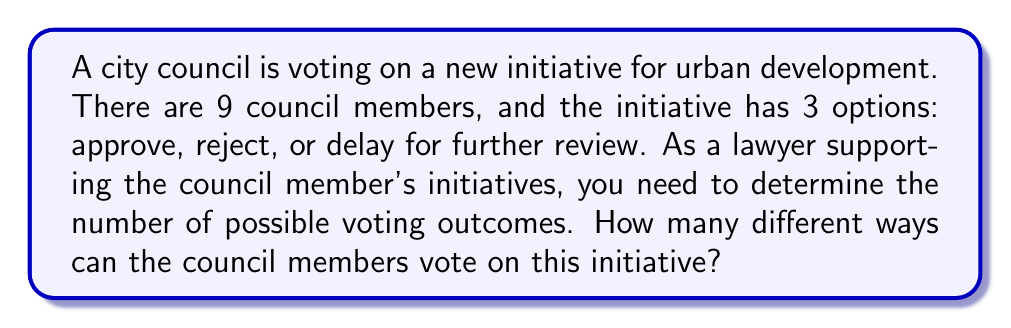Give your solution to this math problem. Let's approach this step-by-step:

1) Each council member has 3 choices: approve, reject, or delay.

2) We need to determine how many ways 9 people can make 3 choices independently.

3) This is a case of the Multiplication Principle. When we have a series of independent choices, we multiply the number of options for each choice.

4) In this case, we have:
   - 3 choices for the first council member
   - 3 choices for the second council member
   - ...
   - 3 choices for the ninth council member

5) Mathematically, this can be expressed as:

   $$3 \times 3 \times 3 \times 3 \times 3 \times 3 \times 3 \times 3 \times 3$$

6) This is equivalent to $3^9$ (3 raised to the power of 9)

7) Calculate:
   $$3^9 = 3 \times 3 \times 3 \times 3 \times 3 \times 3 \times 3 \times 3 \times 3 = 19,683$$

Therefore, there are 19,683 possible voting outcomes for this council initiative.
Answer: $3^9 = 19,683$ 